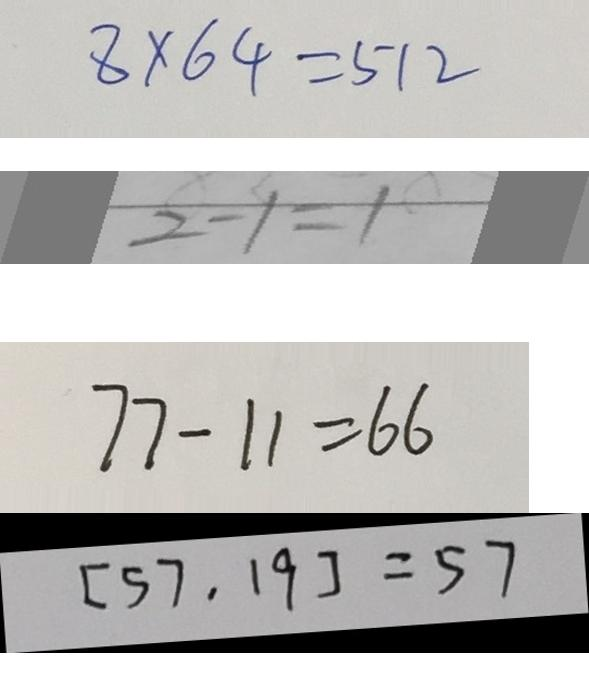Convert formula to latex. <formula><loc_0><loc_0><loc_500><loc_500>8 \times 6 4 = 5 1 2 
 2 - 1 = 1 
 7 7 - 1 1 = 6 6 
 [ 5 7 , 1 9 ] = 5 7</formula> 